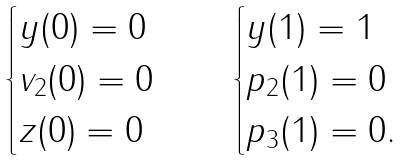<formula> <loc_0><loc_0><loc_500><loc_500>\begin{cases} y ( 0 ) = 0 \\ v _ { 2 } ( 0 ) = 0 \\ z ( 0 ) = 0 \end{cases} \quad \begin{cases} y ( 1 ) = 1 \\ p _ { 2 } ( 1 ) = 0 \\ p _ { 3 } ( 1 ) = 0 . \end{cases}</formula> 